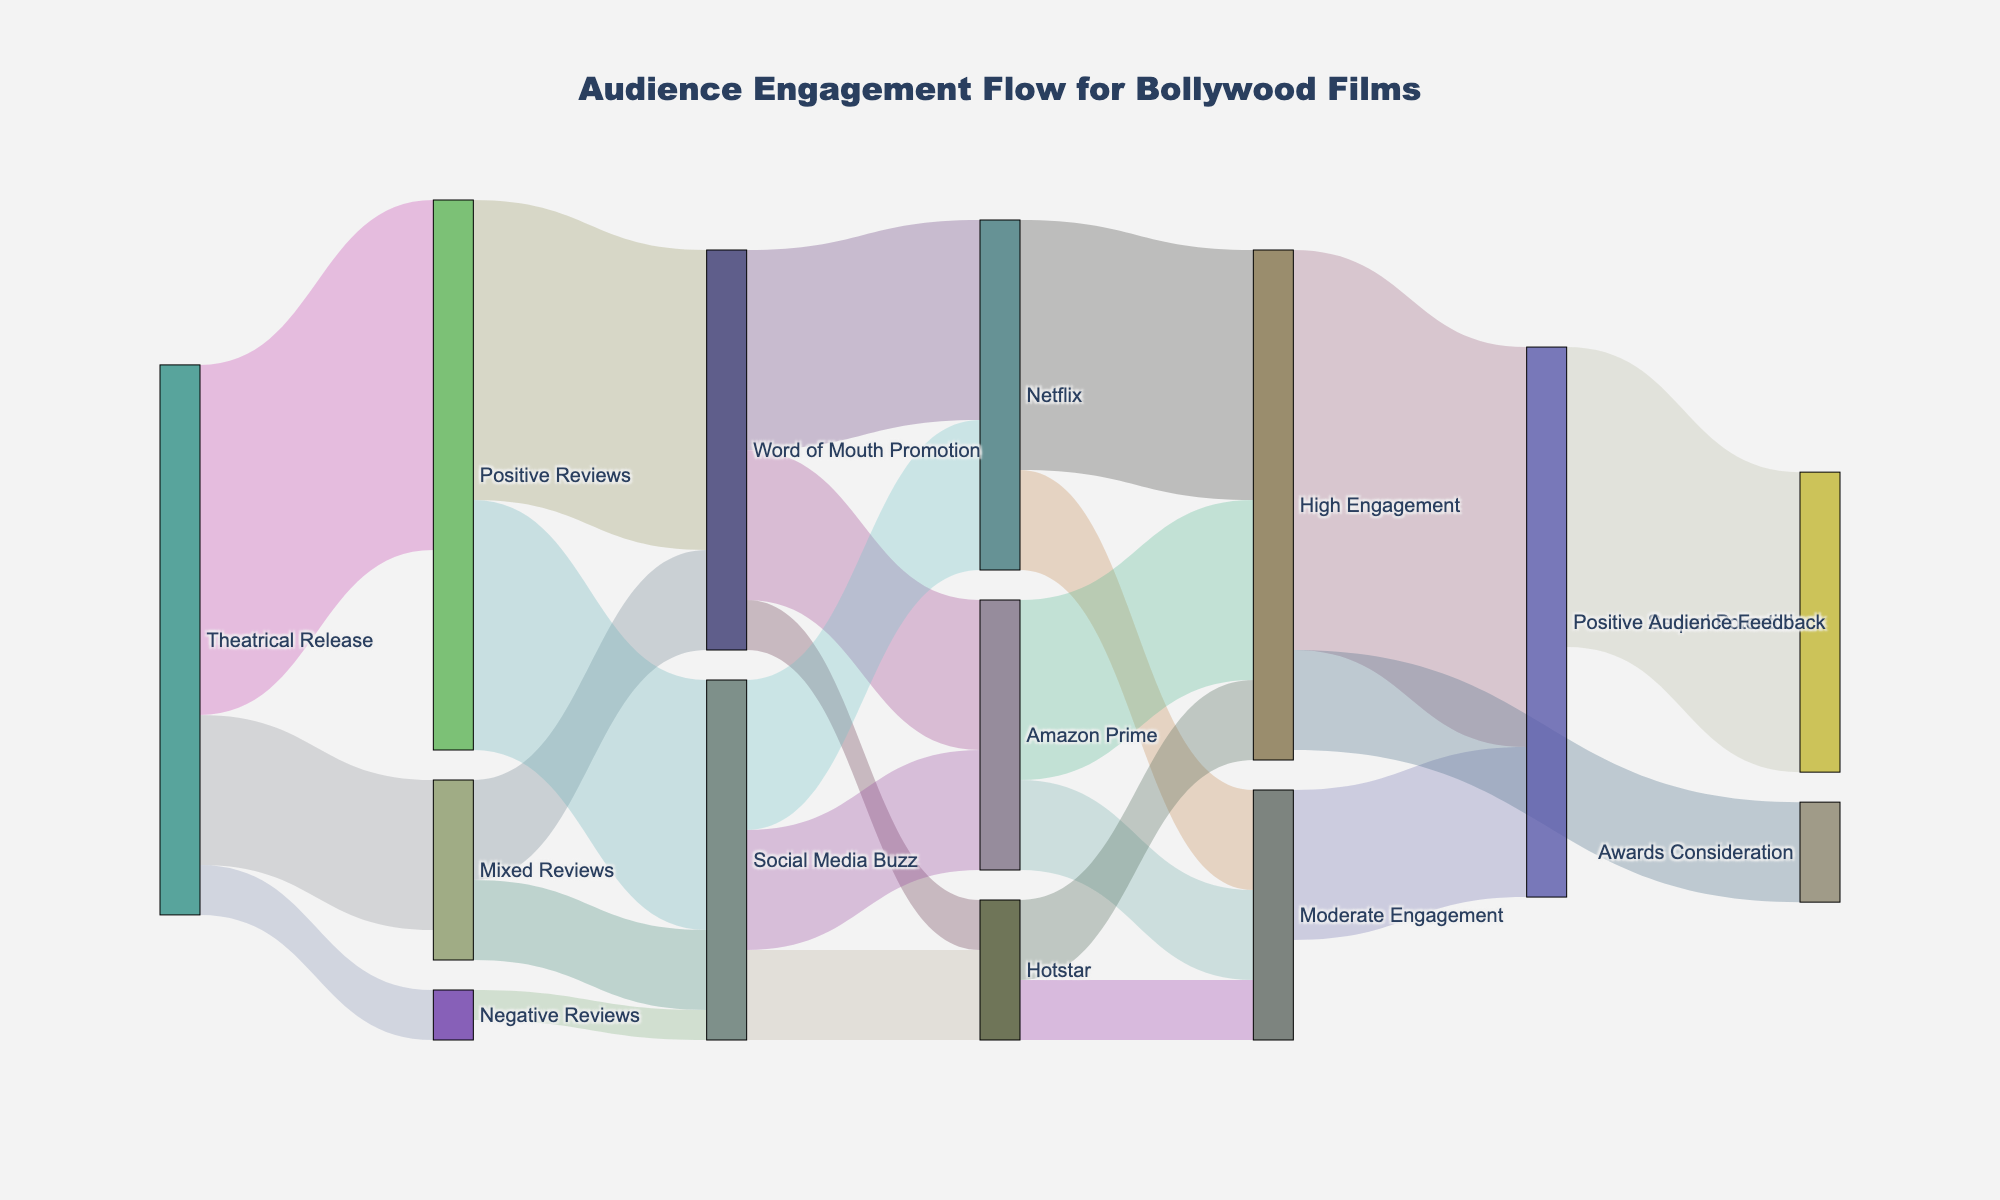How many positive reviews were generated directly from the theatrical release? The Sankey diagram shows the flow of "Positive Reviews" from "Theatrical Release" to "Positive Reviews" with a value of 35.
Answer: 35 What is the total number of reviews (positive, mixed, and negative) generated from the theatrical release? To find the total reviews from the theatrical release, add the values for positive, mixed, and negative reviews: 35 (positive) + 15 (mixed) + 5 (negative) = 55.
Answer: 55 How many viewers were influenced by word-of-mouth promotion to watch the film on Netflix? The diagram indicates the flow from "Word of Mouth Promotion" to "Netflix" with a value of 20.
Answer: 20 Which streaming platform received the highest engagement from social media buzz? Compare the values of "Social Media Buzz" leading to different platforms: Netflix (15), Amazon Prime (12), and Hotstar (9). Netflix has the highest value.
Answer: Netflix What is the combined value of high engagement on Netflix and Amazon Prime? Add the values of "High Engagement" for Netflix (25) and Amazon Prime (18): 25 + 18 = 43.
Answer: 43 How much positive audience feedback was generated from high and moderate engagement combined? Add the values for positive audience feedback from high engagement (40) and moderate engagement (15): 40 + 15 = 55.
Answer: 55 Which step in the flow contributes the most to award considerations? The only path leading to "Awards Consideration" comes from "High Engagement" with a value of 10. Therefore, high engagement contributes the most.
Answer: High Engagement What is the value of sequels' potential derived from positive audience feedback? The flow from "Positive Audience Feedback" to "Sequel Potential" has a value of 30.
Answer: 30 